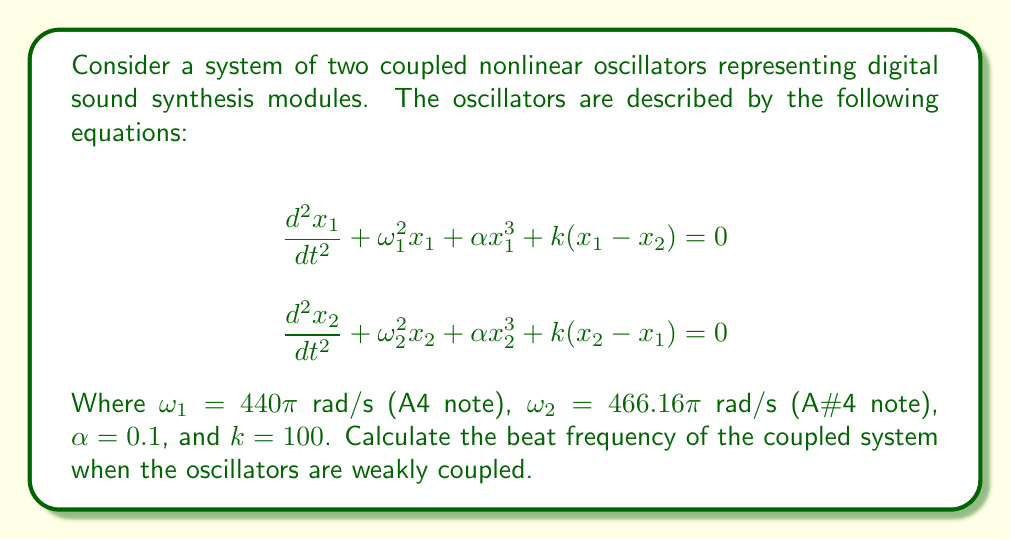Teach me how to tackle this problem. To solve this problem, we'll follow these steps:

1) In a weakly coupled system, the beat frequency is approximately the difference between the natural frequencies of the two oscillators.

2) The natural frequencies of the oscillators are given by $\omega_1$ and $\omega_2$ in rad/s. We need to convert these to Hz:

   $f_1 = \frac{\omega_1}{2\pi} = \frac{440\pi}{2\pi} = 440$ Hz
   $f_2 = \frac{\omega_2}{2\pi} = \frac{466.16\pi}{2\pi} = 466.16$ Hz

3) The beat frequency is the absolute difference between these frequencies:

   $f_{beat} = |f_2 - f_1| = |466.16 - 440| = 26.16$ Hz

4) This result assumes weak coupling. In reality, the coupling strength $k$ and the nonlinear term $\alpha x^3$ would slightly modify this frequency, but for weak coupling, this approximation is sufficient.

5) In music technology, this beat frequency of 26.16 Hz would be perceived as a rhythmic pulsation or tremolo effect when these two tones are played simultaneously.
Answer: 26.16 Hz 